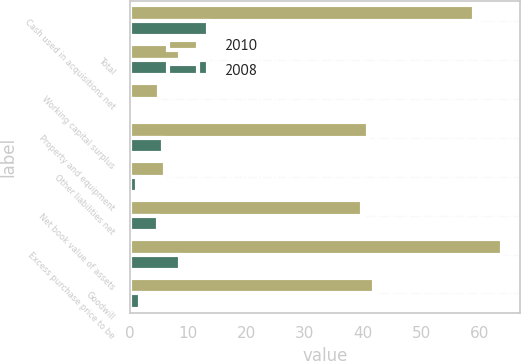Convert chart to OTSL. <chart><loc_0><loc_0><loc_500><loc_500><stacked_bar_chart><ecel><fcel>Cash used in acquisitions net<fcel>Total<fcel>Working capital surplus<fcel>Property and equipment<fcel>Other liabilities net<fcel>Net book value of assets<fcel>Excess purchase price to be<fcel>Goodwill<nl><fcel>2010<fcel>58.9<fcel>8.6<fcel>5.1<fcel>40.8<fcel>6.1<fcel>39.8<fcel>63.7<fcel>41.8<nl><fcel>2008<fcel>13.4<fcel>13.4<fcel>0.4<fcel>5.7<fcel>1.3<fcel>4.8<fcel>8.6<fcel>1.7<nl></chart> 